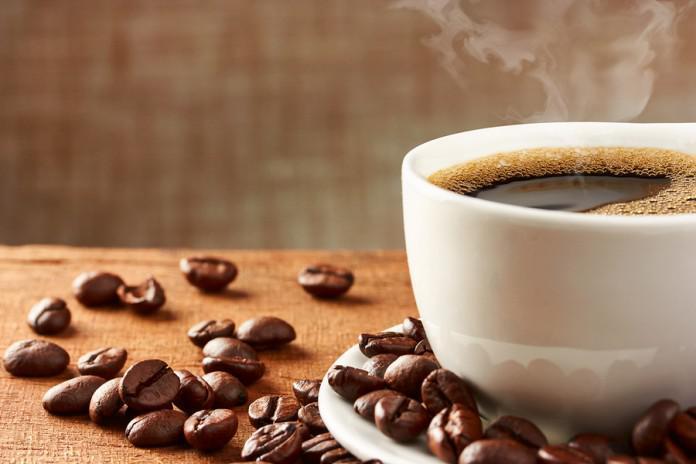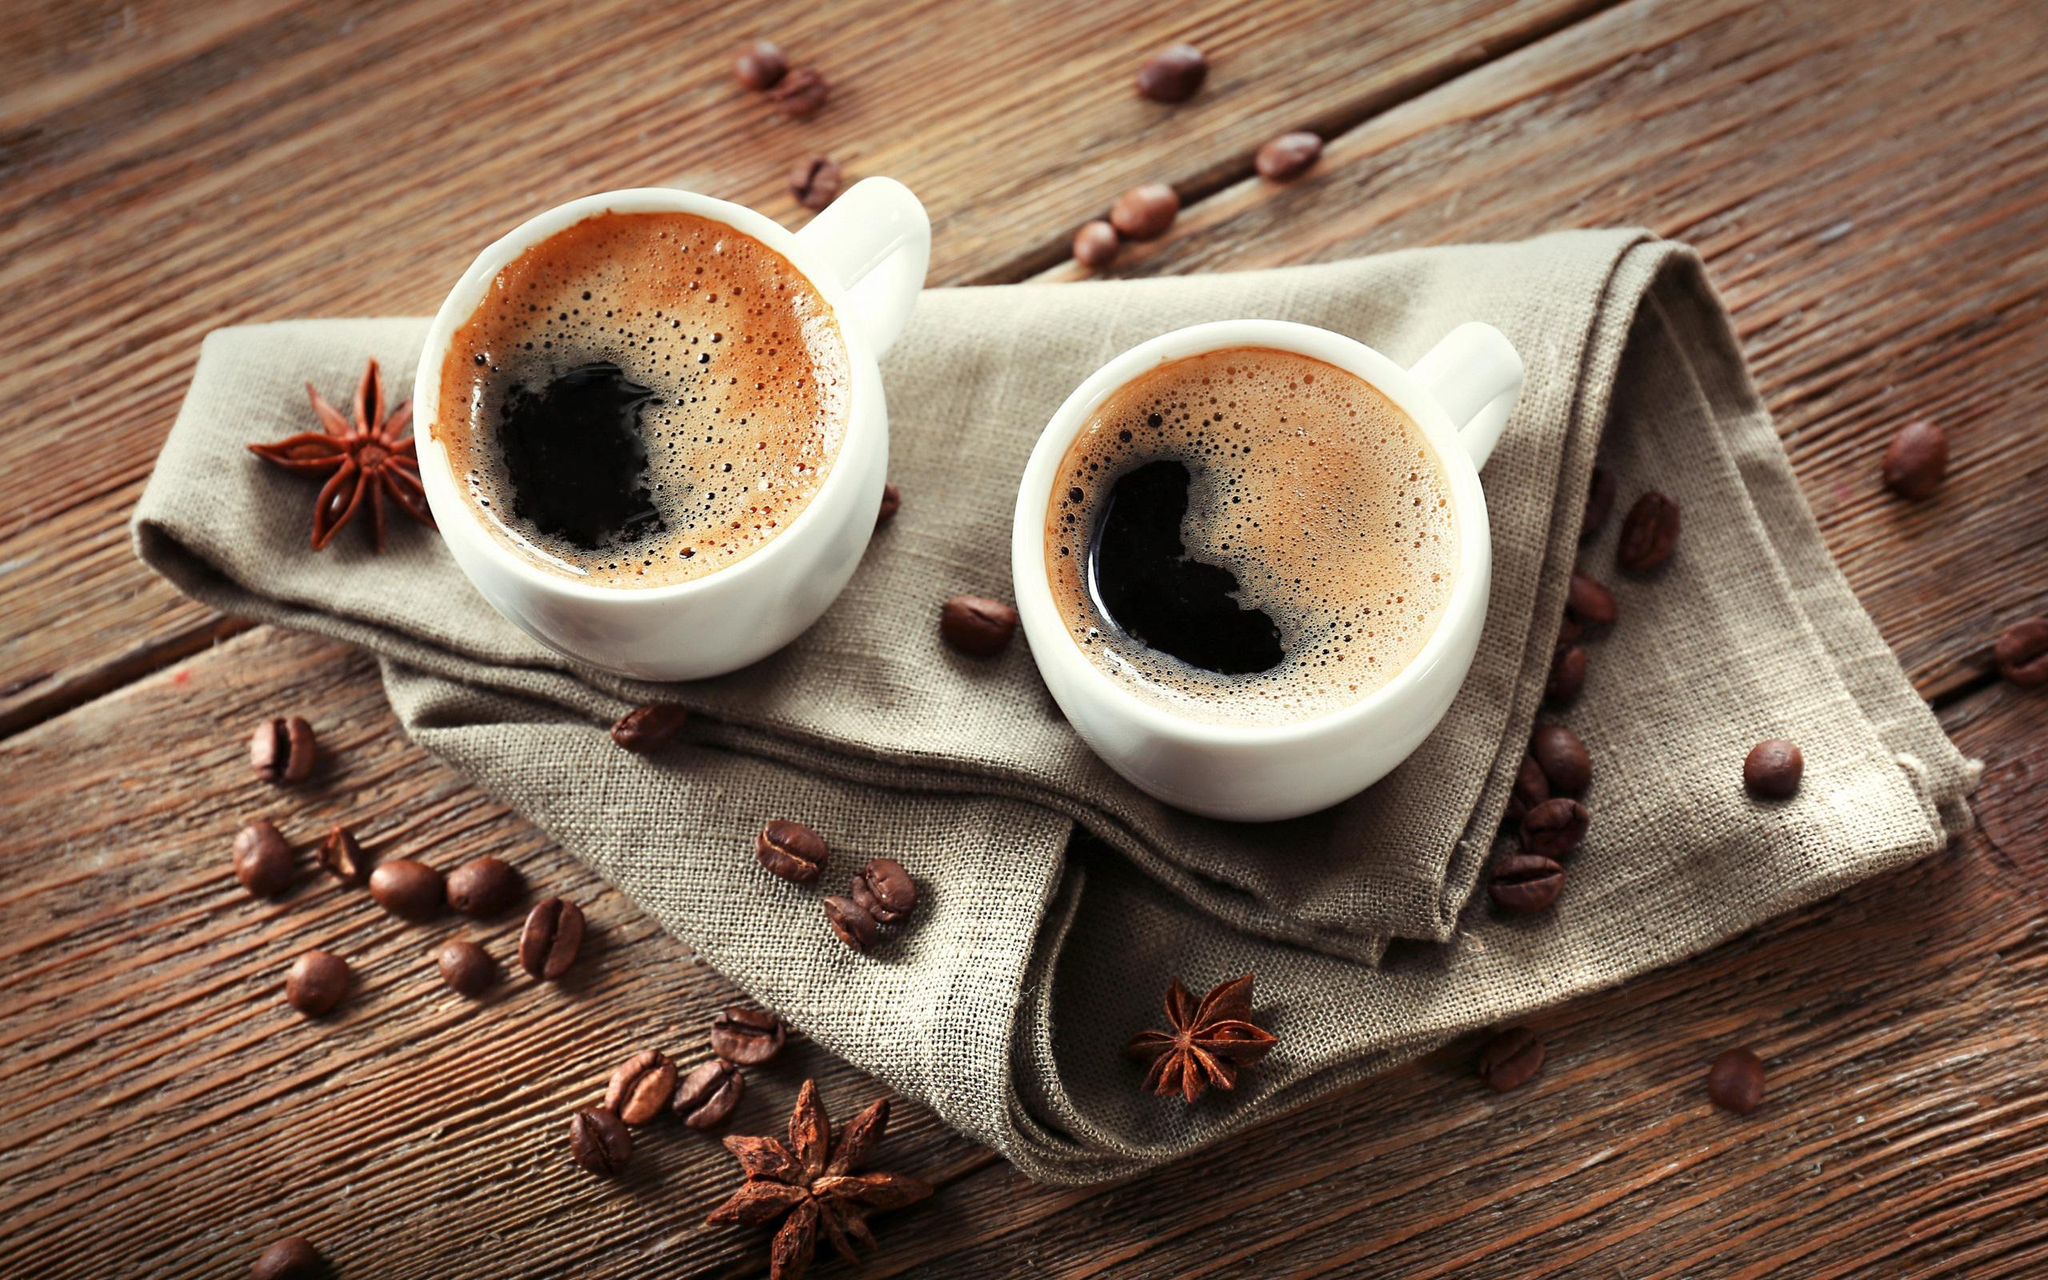The first image is the image on the left, the second image is the image on the right. Examine the images to the left and right. Is the description "There are three cups of coffee on three saucers." accurate? Answer yes or no. No. The first image is the image on the left, the second image is the image on the right. Given the left and right images, does the statement "An image shows one hot beverage in a cup on a saucer that holds a spoon." hold true? Answer yes or no. No. 